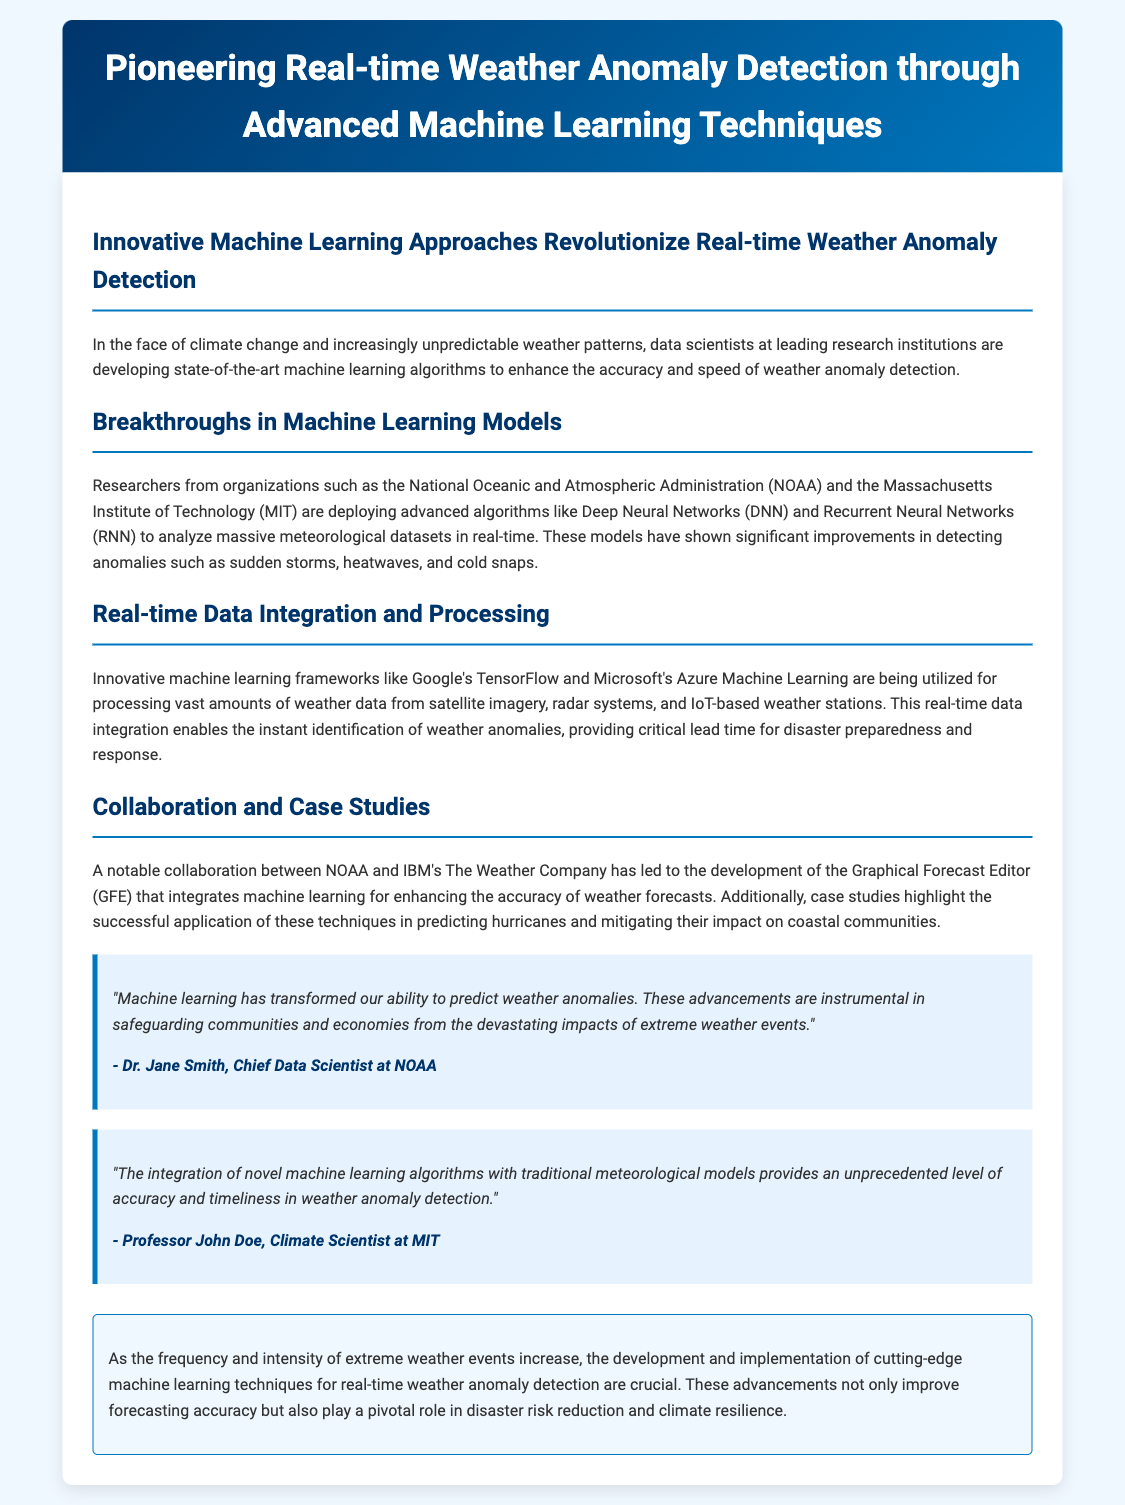what is the main focus of the press release? The press release discusses advancements in machine learning techniques for detecting weather anomalies in real-time.
Answer: real-time weather anomaly detection which institutions are mentioned in the research? The document lists organizations involved in the research, including the National Oceanic and Atmospheric Administration and the Massachusetts Institute of Technology.
Answer: NOAA and MIT what machine learning algorithms are highlighted for anomaly detection? The press release mentions specific algorithms used for detecting weather anomalies.
Answer: Deep Neural Networks (DNN) and Recurrent Neural Networks (RNN) who is quoted as the Chief Data Scientist at NOAA? The document includes a quote from a noted individual, providing their title as well.
Answer: Dr. Jane Smith what did NOAA and IBM collaborate on? The collaboration between NOAA and IBM's The Weather Company led to a specific development mentioned in the document.
Answer: Graphical Forecast Editor (GFE) what is the significance of real-time data integration? The document states the importance of integrating real-time data for specific outcomes in weather detection.
Answer: instant identification of weather anomalies why are the advancements in machine learning crucial? The conclusion section emphasizes the importance of these advancements in a particular context related to weather events.
Answer: disaster risk reduction and climate resilience 